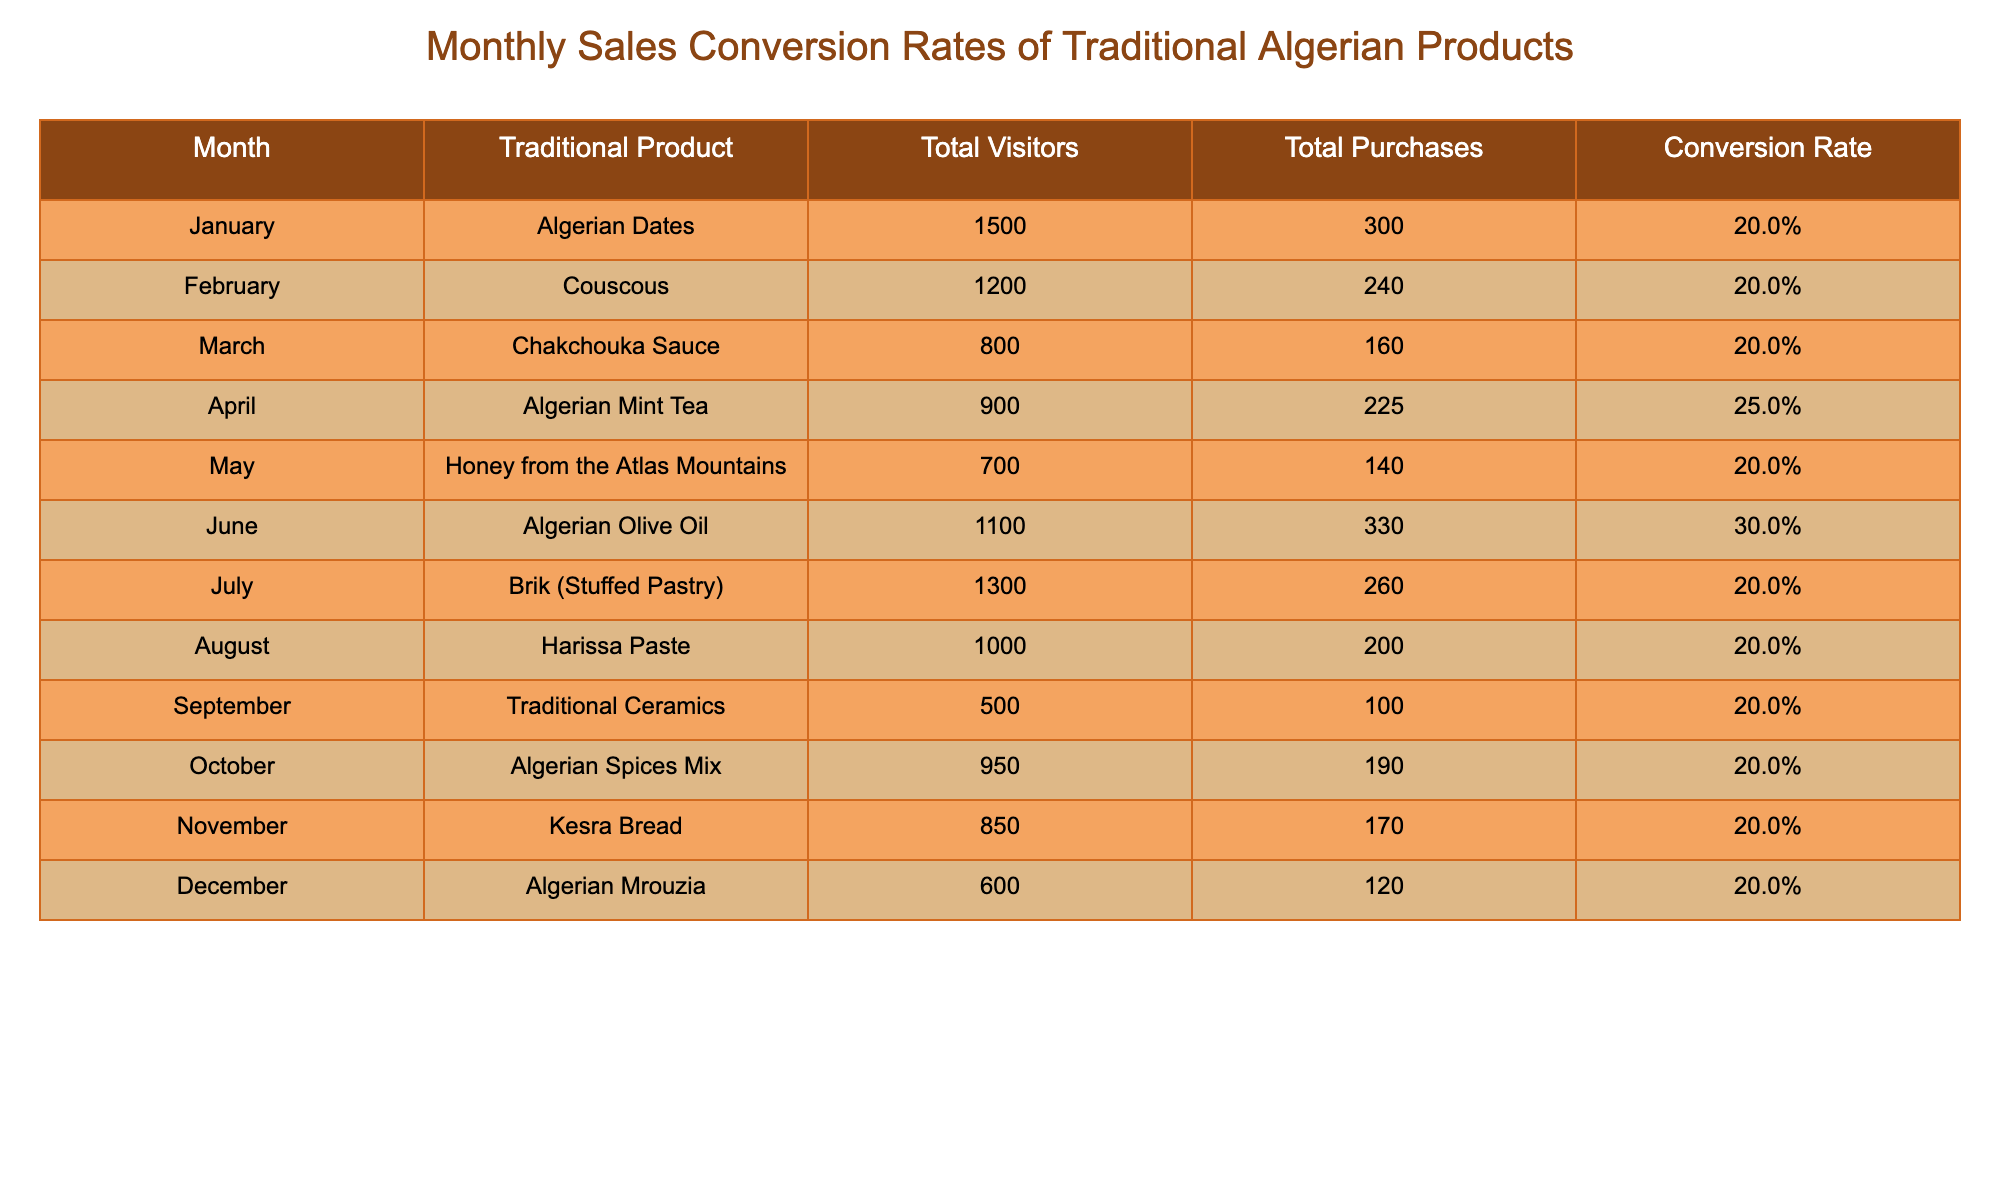What was the conversion rate for Algerian Olive Oil? According to the table, the conversion rate for Algerian Olive Oil in June is 30.0%.
Answer: 30.0% Which traditional product had the highest conversion rate? From the table, Algerian Mint Tea had the highest conversion rate at 25.0% in April.
Answer: Algerian Mint Tea What is the total number of purchases made for Algerian Dates and Couscous combined? To find this, add the purchases for both products: 300 (Algerian Dates) + 240 (Couscous) = 540 total purchases.
Answer: 540 Is the conversion rate for Harissa Paste equal to 20.0%? Yes, the table shows that the conversion rate for Harissa Paste in August is 20.0%.
Answer: Yes What is the average conversion rate for the month of July and October? For July, the conversion rate is 20.0% and for October 20.0%. The average is (20.0% + 20.0%) / 2 = 20.0%.
Answer: 20.0% Which month had a conversion rate lower than 25.0%? Referring to the table, every month except for April (25.0% for Algerian Mint Tea) has a conversion rate of 20.0% or lower, so each of those months qualifies.
Answer: All months except April How many total visitors did Traditional Ceramics have in September? The table clearly indicates that Traditional Ceramics had a total of 500 visitors in September.
Answer: 500 If we sum total purchases from all months, what is the total? To find the total purchases, add each month's purchases: 300 + 240 + 160 + 225 + 140 + 330 + 260 + 200 + 100 + 190 + 170 + 120 = 2290 total purchases.
Answer: 2290 Did Kesra Bread have a conversion rate higher than 20.0%? No, the conversion rate for Kesra Bread in November is 20.0%, which is not higher.
Answer: No 